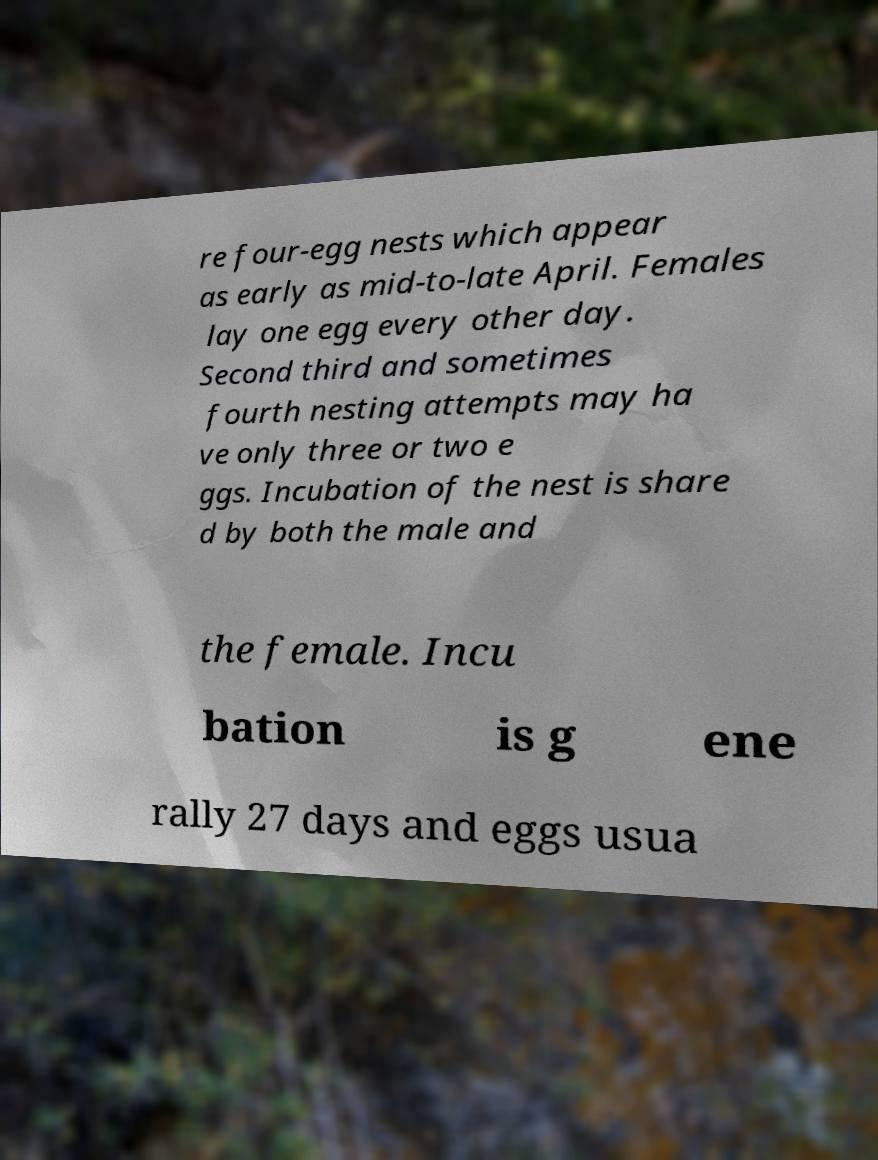Can you accurately transcribe the text from the provided image for me? re four-egg nests which appear as early as mid-to-late April. Females lay one egg every other day. Second third and sometimes fourth nesting attempts may ha ve only three or two e ggs. Incubation of the nest is share d by both the male and the female. Incu bation is g ene rally 27 days and eggs usua 